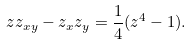<formula> <loc_0><loc_0><loc_500><loc_500>z z _ { x y } - z _ { x } z _ { y } = \frac { 1 } { 4 } ( z ^ { 4 } - 1 ) .</formula> 